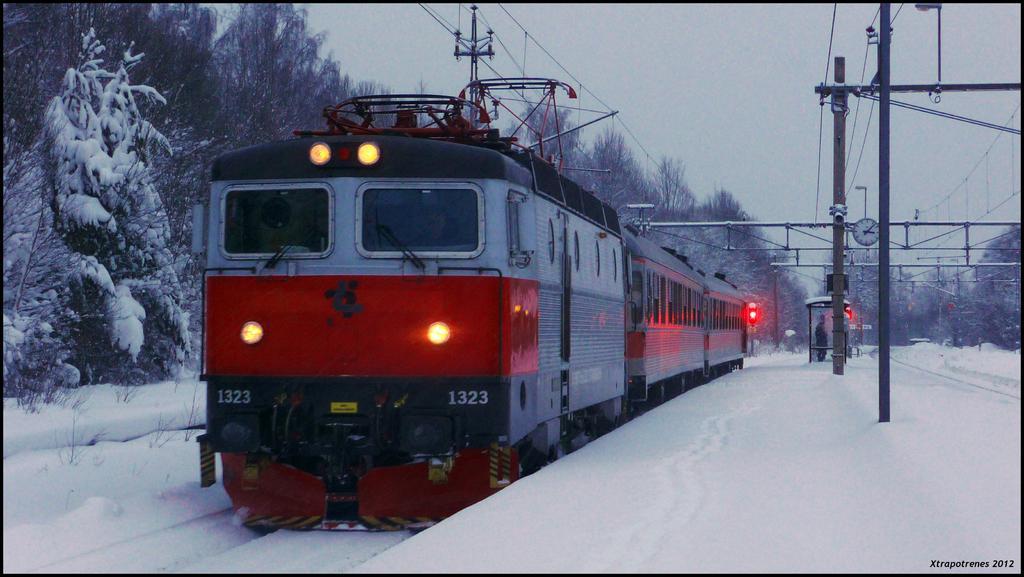Could you give a brief overview of what you see in this image? In this picture we can see red train moving on the track. In the front we can see snow on the ground. Behind we can see some dry trees, iron frame and cables. 